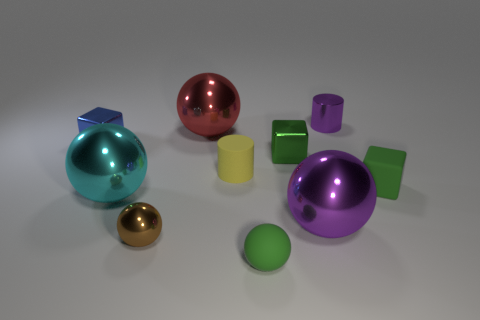Subtract all green spheres. How many spheres are left? 4 Subtract all brown metal balls. How many balls are left? 4 Subtract 1 spheres. How many spheres are left? 4 Subtract all blue balls. Subtract all yellow cubes. How many balls are left? 5 Subtract all blocks. How many objects are left? 7 Add 7 rubber balls. How many rubber balls exist? 8 Subtract 0 blue spheres. How many objects are left? 10 Subtract all big yellow metal objects. Subtract all yellow matte objects. How many objects are left? 9 Add 9 tiny purple things. How many tiny purple things are left? 10 